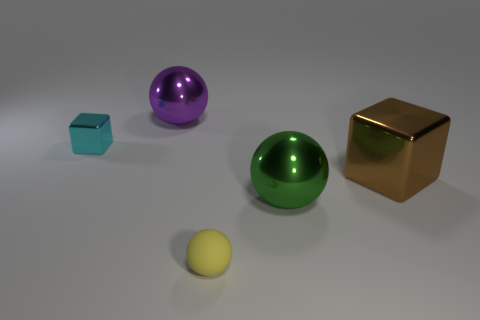Add 4 tiny cyan objects. How many objects exist? 9 Subtract all spheres. How many objects are left? 2 Subtract 1 yellow balls. How many objects are left? 4 Subtract all small spheres. Subtract all tiny green spheres. How many objects are left? 4 Add 4 big things. How many big things are left? 7 Add 5 big metal balls. How many big metal balls exist? 7 